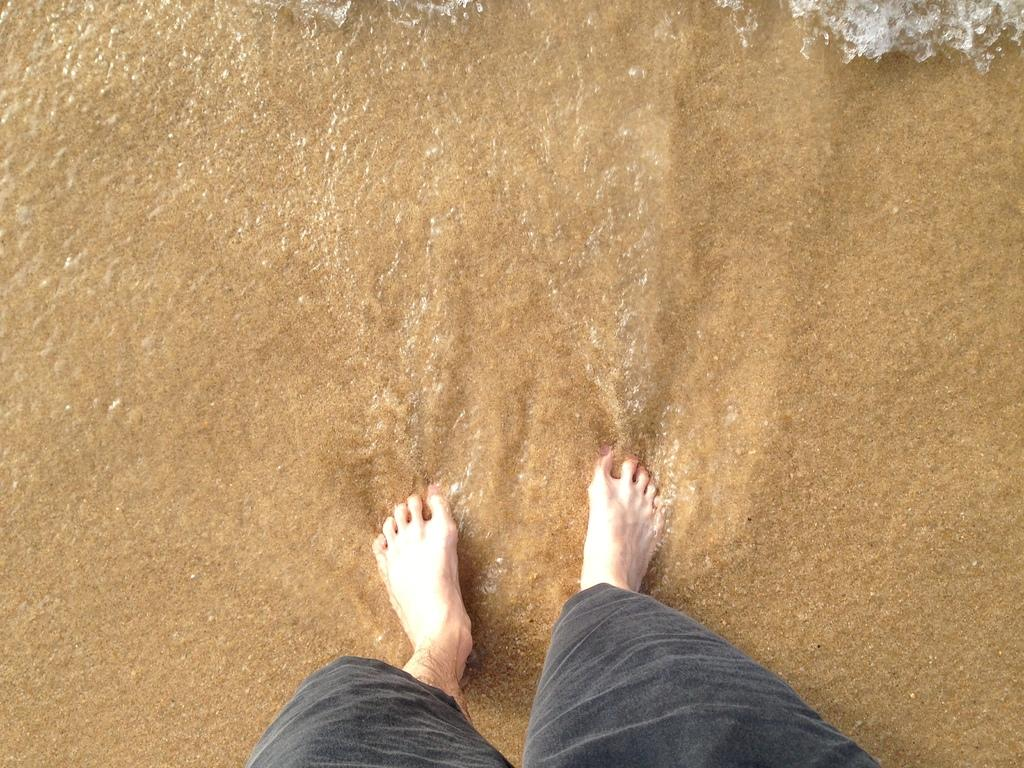What part of a person can be seen in the water in the image? There are legs of a person in the water. What idea does the person have while cooking in the image? There is no indication of cooking or an idea in the image; it only shows legs of a person in the water. 